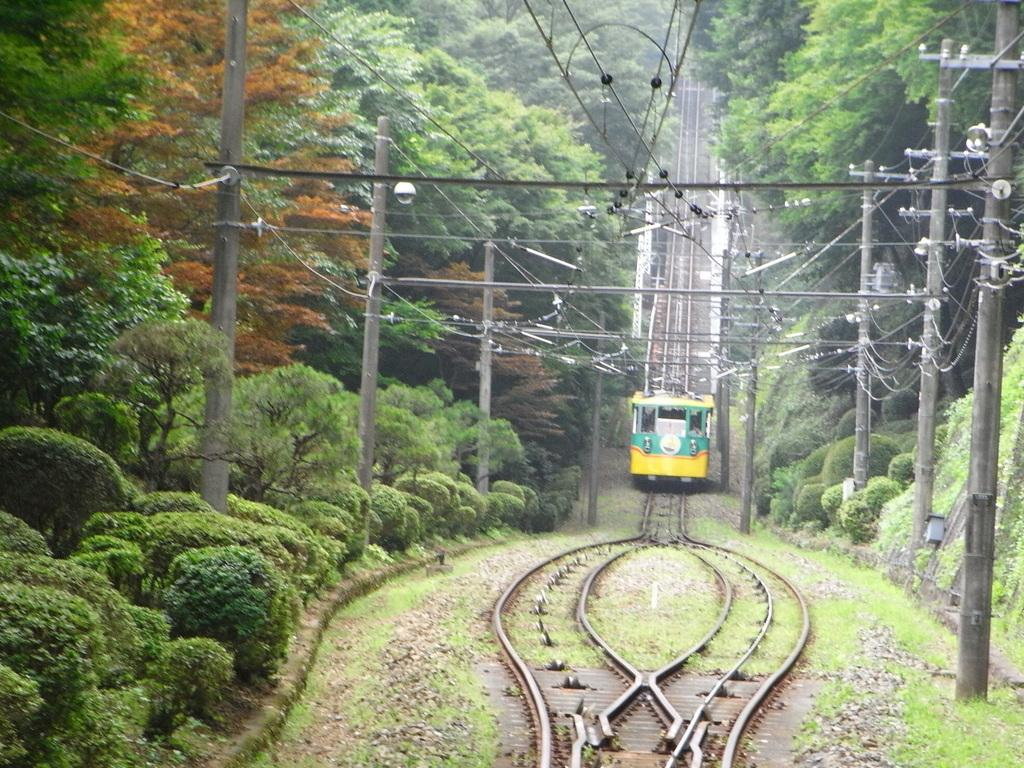What is the main subject of the image? The main subject of the image is a train on the track. What can be seen in the center of the image? There are poles in the center of the image. What type of vegetation is visible in the background of the image? There are trees and bushes in the background of the image. What is visible at the top of the image? There are wires visible at the top of the image. What type of holiday is being celebrated in the image? There is no indication of a holiday being celebrated in the image; it features a train on a track with poles, trees, bushes, and wires. How many children are visible in the image? There are no children present in the image. 